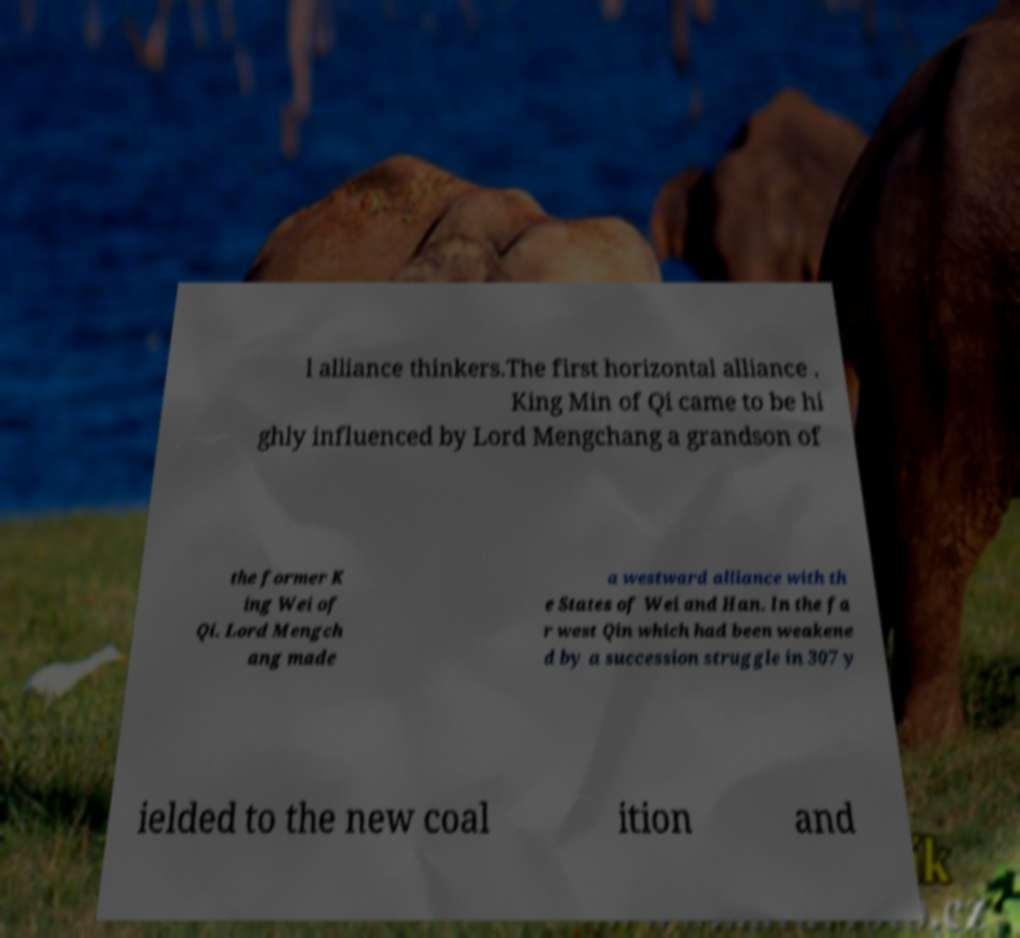Could you extract and type out the text from this image? l alliance thinkers.The first horizontal alliance . King Min of Qi came to be hi ghly influenced by Lord Mengchang a grandson of the former K ing Wei of Qi. Lord Mengch ang made a westward alliance with th e States of Wei and Han. In the fa r west Qin which had been weakene d by a succession struggle in 307 y ielded to the new coal ition and 